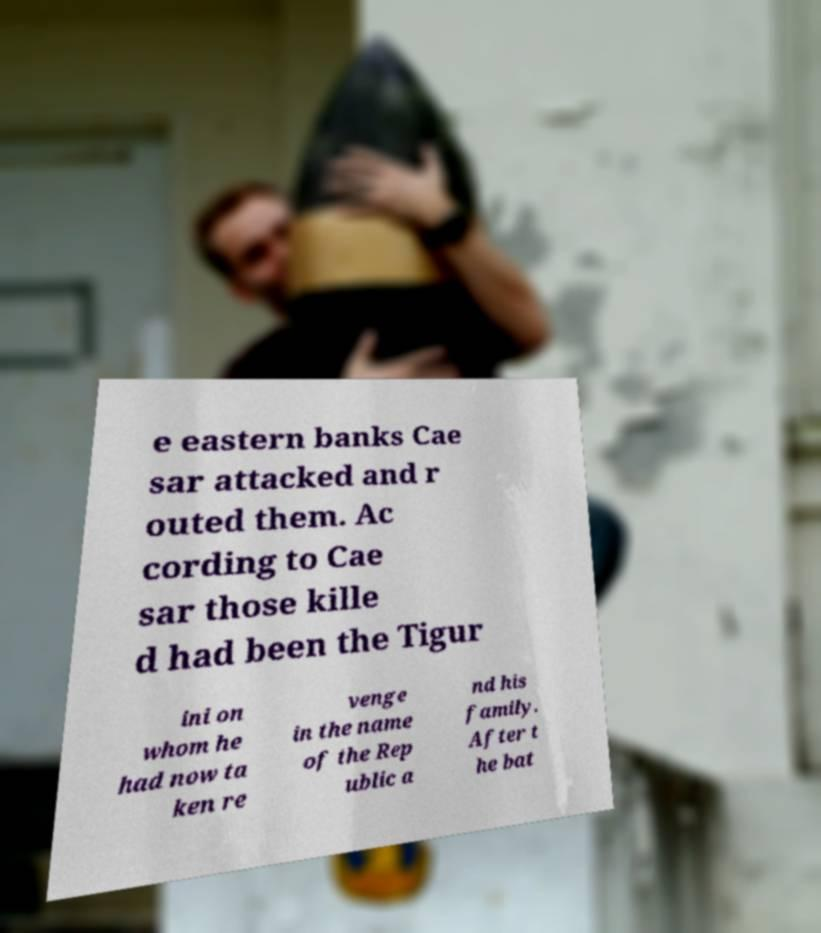What messages or text are displayed in this image? I need them in a readable, typed format. e eastern banks Cae sar attacked and r outed them. Ac cording to Cae sar those kille d had been the Tigur ini on whom he had now ta ken re venge in the name of the Rep ublic a nd his family. After t he bat 